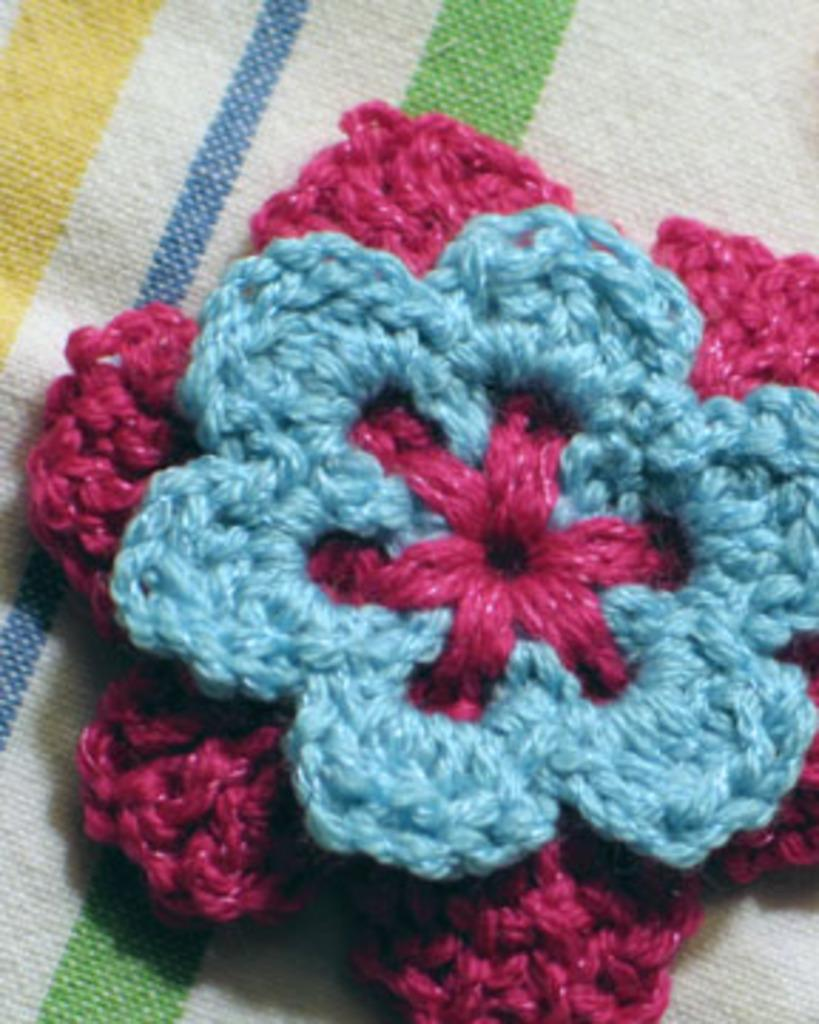What is the main subject in the center of the image? There is a wool cloth in the center of the image. What type of market is depicted in the image? There is no market present in the image; it only features a wool cloth. What kind of crack can be seen in the wool cloth in the image? There is no crack visible in the wool cloth in the image. 